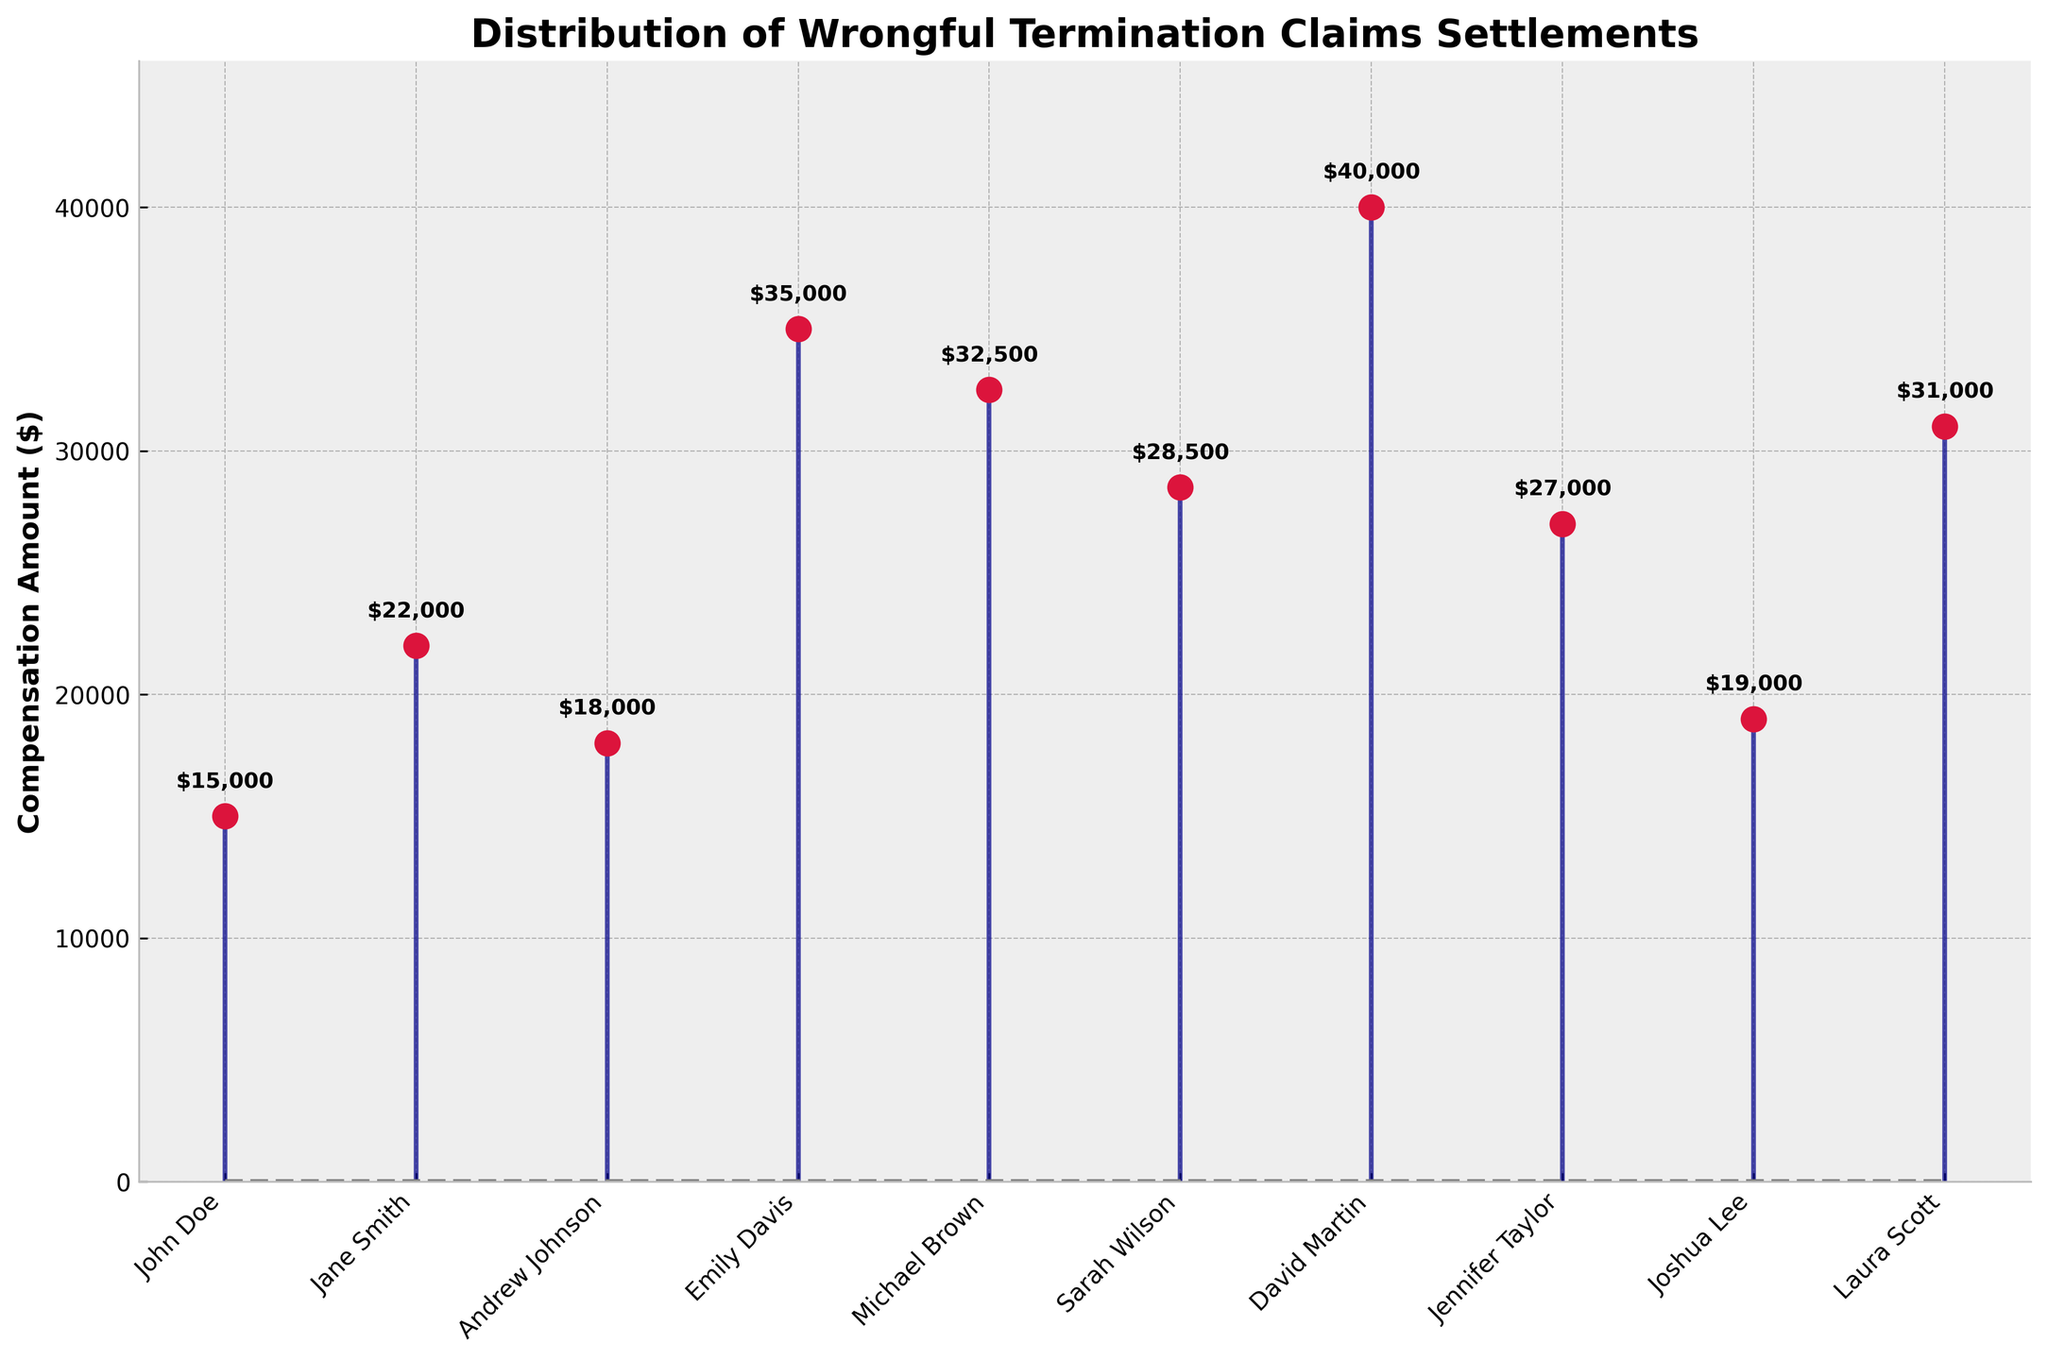What's the title of the figure? The title is usually located at the top of the figure, where it is set in bold to attract attention.
Answer: Distribution of Wrongful Termination Claims Settlements What's the highest compensation amount in the figure? By looking for the longest line extending from the x-axis and noting the value at the end, we find the highest compensation amount. It also helps to look at the text annotations on the plot.
Answer: $40,000 Who received the highest settlement amount? The claimant associated with the highest stem is labeled on the x-axis. The highest stem is for David Martin.
Answer: David Martin What's the range of compensation amounts? To find the range, subtract the smallest value from the largest. The smallest value is John Doe's $15,000 and the largest is David Martin's $40,000.
Answer: $25,000 What's the median compensation amount? To find the median, we need to arrange all compensation amounts in ascending order and find the middle value. Ordered: 15000, 18000, 19000, 22000, 27000, 28500, 31000, 32500, 35000, 40000. The middle values are 27000 and 28500; the median is the average of these two.
Answer: $27,750 Who received a compensation amount close to the median? After calculating the median, we look for claimants with amounts near $27,750. Both Sarah Wilson ($28,500) and Jennifer Taylor ($27,000) are close to this value.
Answer: Sarah Wilson and Jennifer Taylor Which two claimants received the closest compensation amounts? By comparing the values, we find that Joshua Lee ($19,000) and Andrew Johnson ($18,000) have the closest compensation amounts—a difference of $1,000.
Answer: Joshua Lee and Andrew Johnson Who received more compensation: Michael Brown or Laura Scott? Find the bars corresponding to these claimants and compare their heights, Michael Brown's stem reaches $32,500 while Laura Scott’s reaches $31,000.
Answer: Michael Brown What's the total compensation amount for all claimants? Add up all the compensation amounts: $15,000 + $22,000 + $18,000 + $35,000 + $32,500 + $28,500 + $40,000 + $27,000 + $19,000 + $31,000 = $268,000.
Answer: $268,000 What's the average compensation amount? Divide the total compensation amount by the number of claimants. There are 10 claimants, so average = $268,000 / 10 = $26,800.
Answer: $26,800 